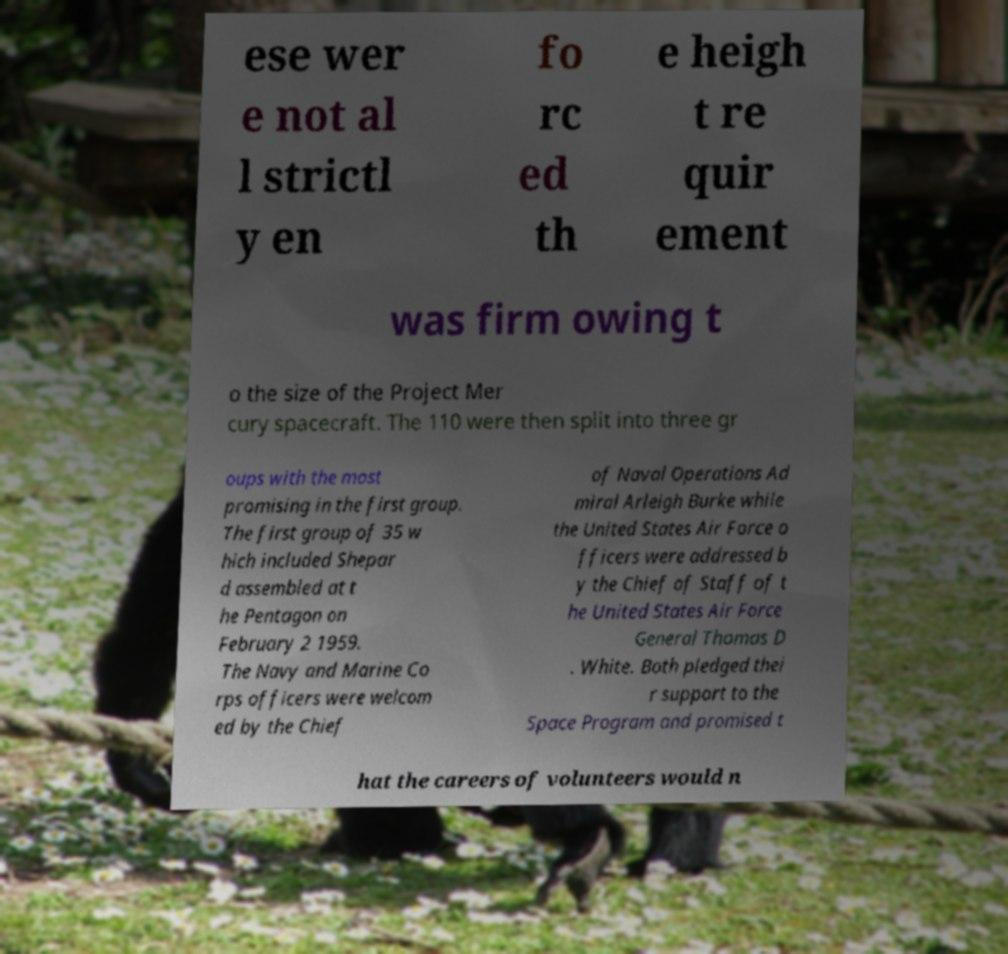Please read and relay the text visible in this image. What does it say? ese wer e not al l strictl y en fo rc ed th e heigh t re quir ement was firm owing t o the size of the Project Mer cury spacecraft. The 110 were then split into three gr oups with the most promising in the first group. The first group of 35 w hich included Shepar d assembled at t he Pentagon on February 2 1959. The Navy and Marine Co rps officers were welcom ed by the Chief of Naval Operations Ad miral Arleigh Burke while the United States Air Force o fficers were addressed b y the Chief of Staff of t he United States Air Force General Thomas D . White. Both pledged thei r support to the Space Program and promised t hat the careers of volunteers would n 